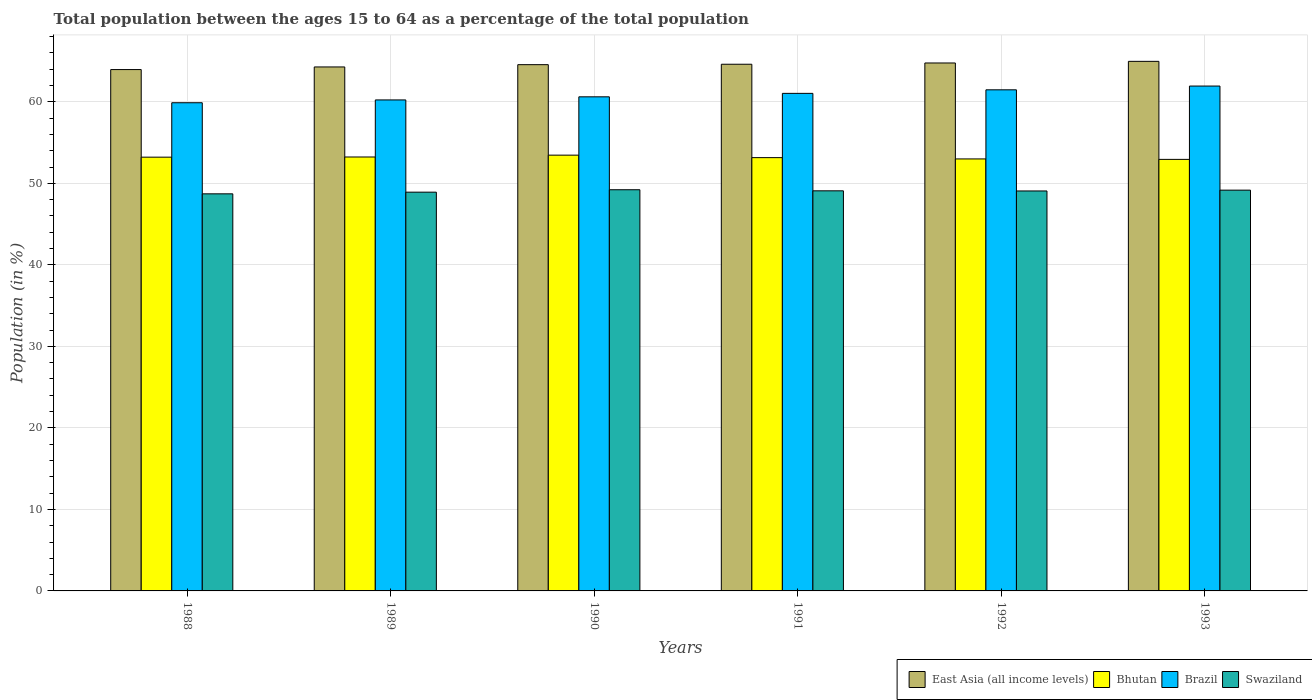How many groups of bars are there?
Make the answer very short. 6. How many bars are there on the 2nd tick from the left?
Keep it short and to the point. 4. How many bars are there on the 4th tick from the right?
Give a very brief answer. 4. In how many cases, is the number of bars for a given year not equal to the number of legend labels?
Keep it short and to the point. 0. What is the percentage of the population ages 15 to 64 in Bhutan in 1991?
Provide a short and direct response. 53.15. Across all years, what is the maximum percentage of the population ages 15 to 64 in East Asia (all income levels)?
Keep it short and to the point. 64.96. Across all years, what is the minimum percentage of the population ages 15 to 64 in East Asia (all income levels)?
Offer a terse response. 63.95. In which year was the percentage of the population ages 15 to 64 in Swaziland maximum?
Offer a terse response. 1990. What is the total percentage of the population ages 15 to 64 in East Asia (all income levels) in the graph?
Make the answer very short. 387.11. What is the difference between the percentage of the population ages 15 to 64 in Brazil in 1989 and that in 1993?
Give a very brief answer. -1.7. What is the difference between the percentage of the population ages 15 to 64 in East Asia (all income levels) in 1992 and the percentage of the population ages 15 to 64 in Brazil in 1993?
Provide a succinct answer. 2.83. What is the average percentage of the population ages 15 to 64 in East Asia (all income levels) per year?
Provide a short and direct response. 64.52. In the year 1992, what is the difference between the percentage of the population ages 15 to 64 in Swaziland and percentage of the population ages 15 to 64 in Brazil?
Ensure brevity in your answer.  -12.41. In how many years, is the percentage of the population ages 15 to 64 in East Asia (all income levels) greater than 6?
Offer a very short reply. 6. What is the ratio of the percentage of the population ages 15 to 64 in Swaziland in 1988 to that in 1989?
Ensure brevity in your answer.  1. Is the percentage of the population ages 15 to 64 in Bhutan in 1989 less than that in 1991?
Keep it short and to the point. No. What is the difference between the highest and the second highest percentage of the population ages 15 to 64 in Bhutan?
Provide a succinct answer. 0.23. What is the difference between the highest and the lowest percentage of the population ages 15 to 64 in Bhutan?
Make the answer very short. 0.52. In how many years, is the percentage of the population ages 15 to 64 in East Asia (all income levels) greater than the average percentage of the population ages 15 to 64 in East Asia (all income levels) taken over all years?
Your answer should be very brief. 4. What does the 2nd bar from the left in 1992 represents?
Give a very brief answer. Bhutan. Is it the case that in every year, the sum of the percentage of the population ages 15 to 64 in East Asia (all income levels) and percentage of the population ages 15 to 64 in Brazil is greater than the percentage of the population ages 15 to 64 in Bhutan?
Offer a very short reply. Yes. How many bars are there?
Offer a very short reply. 24. What is the difference between two consecutive major ticks on the Y-axis?
Ensure brevity in your answer.  10. Are the values on the major ticks of Y-axis written in scientific E-notation?
Make the answer very short. No. Does the graph contain any zero values?
Your answer should be very brief. No. Does the graph contain grids?
Keep it short and to the point. Yes. Where does the legend appear in the graph?
Your answer should be very brief. Bottom right. How many legend labels are there?
Offer a very short reply. 4. What is the title of the graph?
Your answer should be very brief. Total population between the ages 15 to 64 as a percentage of the total population. Does "East Asia (all income levels)" appear as one of the legend labels in the graph?
Give a very brief answer. Yes. What is the label or title of the X-axis?
Offer a terse response. Years. What is the label or title of the Y-axis?
Ensure brevity in your answer.  Population (in %). What is the Population (in %) of East Asia (all income levels) in 1988?
Keep it short and to the point. 63.95. What is the Population (in %) in Bhutan in 1988?
Make the answer very short. 53.21. What is the Population (in %) of Brazil in 1988?
Your answer should be compact. 59.88. What is the Population (in %) of Swaziland in 1988?
Make the answer very short. 48.71. What is the Population (in %) in East Asia (all income levels) in 1989?
Your answer should be compact. 64.27. What is the Population (in %) of Bhutan in 1989?
Your answer should be very brief. 53.23. What is the Population (in %) of Brazil in 1989?
Make the answer very short. 60.23. What is the Population (in %) in Swaziland in 1989?
Your response must be concise. 48.92. What is the Population (in %) of East Asia (all income levels) in 1990?
Provide a succinct answer. 64.55. What is the Population (in %) of Bhutan in 1990?
Keep it short and to the point. 53.45. What is the Population (in %) of Brazil in 1990?
Offer a very short reply. 60.61. What is the Population (in %) of Swaziland in 1990?
Your response must be concise. 49.21. What is the Population (in %) of East Asia (all income levels) in 1991?
Your answer should be very brief. 64.61. What is the Population (in %) in Bhutan in 1991?
Ensure brevity in your answer.  53.15. What is the Population (in %) in Brazil in 1991?
Keep it short and to the point. 61.03. What is the Population (in %) in Swaziland in 1991?
Keep it short and to the point. 49.08. What is the Population (in %) of East Asia (all income levels) in 1992?
Make the answer very short. 64.76. What is the Population (in %) in Bhutan in 1992?
Give a very brief answer. 52.99. What is the Population (in %) of Brazil in 1992?
Offer a very short reply. 61.47. What is the Population (in %) of Swaziland in 1992?
Offer a very short reply. 49.06. What is the Population (in %) of East Asia (all income levels) in 1993?
Your answer should be compact. 64.96. What is the Population (in %) of Bhutan in 1993?
Your answer should be compact. 52.94. What is the Population (in %) of Brazil in 1993?
Your answer should be compact. 61.93. What is the Population (in %) of Swaziland in 1993?
Make the answer very short. 49.16. Across all years, what is the maximum Population (in %) in East Asia (all income levels)?
Your response must be concise. 64.96. Across all years, what is the maximum Population (in %) of Bhutan?
Offer a terse response. 53.45. Across all years, what is the maximum Population (in %) in Brazil?
Provide a short and direct response. 61.93. Across all years, what is the maximum Population (in %) of Swaziland?
Provide a short and direct response. 49.21. Across all years, what is the minimum Population (in %) of East Asia (all income levels)?
Provide a succinct answer. 63.95. Across all years, what is the minimum Population (in %) of Bhutan?
Your response must be concise. 52.94. Across all years, what is the minimum Population (in %) of Brazil?
Give a very brief answer. 59.88. Across all years, what is the minimum Population (in %) in Swaziland?
Ensure brevity in your answer.  48.71. What is the total Population (in %) of East Asia (all income levels) in the graph?
Provide a short and direct response. 387.11. What is the total Population (in %) of Bhutan in the graph?
Provide a succinct answer. 318.97. What is the total Population (in %) of Brazil in the graph?
Ensure brevity in your answer.  365.16. What is the total Population (in %) in Swaziland in the graph?
Ensure brevity in your answer.  294.14. What is the difference between the Population (in %) of East Asia (all income levels) in 1988 and that in 1989?
Your response must be concise. -0.32. What is the difference between the Population (in %) in Bhutan in 1988 and that in 1989?
Keep it short and to the point. -0.02. What is the difference between the Population (in %) in Brazil in 1988 and that in 1989?
Provide a short and direct response. -0.35. What is the difference between the Population (in %) of Swaziland in 1988 and that in 1989?
Your answer should be very brief. -0.2. What is the difference between the Population (in %) of East Asia (all income levels) in 1988 and that in 1990?
Your response must be concise. -0.6. What is the difference between the Population (in %) of Bhutan in 1988 and that in 1990?
Ensure brevity in your answer.  -0.25. What is the difference between the Population (in %) of Brazil in 1988 and that in 1990?
Your answer should be compact. -0.73. What is the difference between the Population (in %) of Swaziland in 1988 and that in 1990?
Offer a very short reply. -0.5. What is the difference between the Population (in %) in East Asia (all income levels) in 1988 and that in 1991?
Ensure brevity in your answer.  -0.65. What is the difference between the Population (in %) of Bhutan in 1988 and that in 1991?
Offer a terse response. 0.06. What is the difference between the Population (in %) in Brazil in 1988 and that in 1991?
Offer a very short reply. -1.15. What is the difference between the Population (in %) in Swaziland in 1988 and that in 1991?
Provide a succinct answer. -0.37. What is the difference between the Population (in %) in East Asia (all income levels) in 1988 and that in 1992?
Give a very brief answer. -0.81. What is the difference between the Population (in %) in Bhutan in 1988 and that in 1992?
Your answer should be compact. 0.22. What is the difference between the Population (in %) of Brazil in 1988 and that in 1992?
Offer a very short reply. -1.59. What is the difference between the Population (in %) of Swaziland in 1988 and that in 1992?
Provide a short and direct response. -0.35. What is the difference between the Population (in %) of East Asia (all income levels) in 1988 and that in 1993?
Keep it short and to the point. -1.01. What is the difference between the Population (in %) of Bhutan in 1988 and that in 1993?
Provide a short and direct response. 0.27. What is the difference between the Population (in %) in Brazil in 1988 and that in 1993?
Your response must be concise. -2.05. What is the difference between the Population (in %) of Swaziland in 1988 and that in 1993?
Your answer should be very brief. -0.45. What is the difference between the Population (in %) in East Asia (all income levels) in 1989 and that in 1990?
Provide a succinct answer. -0.28. What is the difference between the Population (in %) of Bhutan in 1989 and that in 1990?
Make the answer very short. -0.23. What is the difference between the Population (in %) in Brazil in 1989 and that in 1990?
Your answer should be very brief. -0.38. What is the difference between the Population (in %) in Swaziland in 1989 and that in 1990?
Your response must be concise. -0.3. What is the difference between the Population (in %) in East Asia (all income levels) in 1989 and that in 1991?
Provide a short and direct response. -0.33. What is the difference between the Population (in %) of Bhutan in 1989 and that in 1991?
Offer a terse response. 0.08. What is the difference between the Population (in %) of Brazil in 1989 and that in 1991?
Your answer should be compact. -0.81. What is the difference between the Population (in %) of Swaziland in 1989 and that in 1991?
Give a very brief answer. -0.16. What is the difference between the Population (in %) of East Asia (all income levels) in 1989 and that in 1992?
Make the answer very short. -0.49. What is the difference between the Population (in %) of Bhutan in 1989 and that in 1992?
Provide a succinct answer. 0.24. What is the difference between the Population (in %) in Brazil in 1989 and that in 1992?
Give a very brief answer. -1.24. What is the difference between the Population (in %) in Swaziland in 1989 and that in 1992?
Your response must be concise. -0.15. What is the difference between the Population (in %) of East Asia (all income levels) in 1989 and that in 1993?
Give a very brief answer. -0.69. What is the difference between the Population (in %) of Bhutan in 1989 and that in 1993?
Ensure brevity in your answer.  0.29. What is the difference between the Population (in %) of Brazil in 1989 and that in 1993?
Your response must be concise. -1.7. What is the difference between the Population (in %) of Swaziland in 1989 and that in 1993?
Offer a very short reply. -0.25. What is the difference between the Population (in %) in East Asia (all income levels) in 1990 and that in 1991?
Your response must be concise. -0.05. What is the difference between the Population (in %) of Bhutan in 1990 and that in 1991?
Offer a very short reply. 0.3. What is the difference between the Population (in %) in Brazil in 1990 and that in 1991?
Offer a very short reply. -0.42. What is the difference between the Population (in %) in Swaziland in 1990 and that in 1991?
Provide a short and direct response. 0.13. What is the difference between the Population (in %) of East Asia (all income levels) in 1990 and that in 1992?
Your response must be concise. -0.21. What is the difference between the Population (in %) of Bhutan in 1990 and that in 1992?
Your answer should be compact. 0.46. What is the difference between the Population (in %) of Brazil in 1990 and that in 1992?
Provide a succinct answer. -0.86. What is the difference between the Population (in %) in Swaziland in 1990 and that in 1992?
Make the answer very short. 0.15. What is the difference between the Population (in %) in East Asia (all income levels) in 1990 and that in 1993?
Provide a short and direct response. -0.41. What is the difference between the Population (in %) of Bhutan in 1990 and that in 1993?
Give a very brief answer. 0.52. What is the difference between the Population (in %) in Brazil in 1990 and that in 1993?
Offer a terse response. -1.32. What is the difference between the Population (in %) of Swaziland in 1990 and that in 1993?
Your answer should be very brief. 0.05. What is the difference between the Population (in %) of East Asia (all income levels) in 1991 and that in 1992?
Provide a succinct answer. -0.15. What is the difference between the Population (in %) of Bhutan in 1991 and that in 1992?
Offer a terse response. 0.16. What is the difference between the Population (in %) in Brazil in 1991 and that in 1992?
Your response must be concise. -0.44. What is the difference between the Population (in %) in Swaziland in 1991 and that in 1992?
Give a very brief answer. 0.02. What is the difference between the Population (in %) of East Asia (all income levels) in 1991 and that in 1993?
Make the answer very short. -0.35. What is the difference between the Population (in %) of Bhutan in 1991 and that in 1993?
Your answer should be compact. 0.22. What is the difference between the Population (in %) in Brazil in 1991 and that in 1993?
Provide a short and direct response. -0.9. What is the difference between the Population (in %) of Swaziland in 1991 and that in 1993?
Make the answer very short. -0.08. What is the difference between the Population (in %) of East Asia (all income levels) in 1992 and that in 1993?
Your response must be concise. -0.2. What is the difference between the Population (in %) of Bhutan in 1992 and that in 1993?
Provide a short and direct response. 0.06. What is the difference between the Population (in %) of Brazil in 1992 and that in 1993?
Make the answer very short. -0.46. What is the difference between the Population (in %) in Swaziland in 1992 and that in 1993?
Make the answer very short. -0.1. What is the difference between the Population (in %) in East Asia (all income levels) in 1988 and the Population (in %) in Bhutan in 1989?
Your answer should be compact. 10.72. What is the difference between the Population (in %) of East Asia (all income levels) in 1988 and the Population (in %) of Brazil in 1989?
Your response must be concise. 3.72. What is the difference between the Population (in %) in East Asia (all income levels) in 1988 and the Population (in %) in Swaziland in 1989?
Make the answer very short. 15.04. What is the difference between the Population (in %) of Bhutan in 1988 and the Population (in %) of Brazil in 1989?
Keep it short and to the point. -7.02. What is the difference between the Population (in %) of Bhutan in 1988 and the Population (in %) of Swaziland in 1989?
Provide a succinct answer. 4.29. What is the difference between the Population (in %) of Brazil in 1988 and the Population (in %) of Swaziland in 1989?
Offer a very short reply. 10.97. What is the difference between the Population (in %) in East Asia (all income levels) in 1988 and the Population (in %) in Bhutan in 1990?
Make the answer very short. 10.5. What is the difference between the Population (in %) of East Asia (all income levels) in 1988 and the Population (in %) of Brazil in 1990?
Ensure brevity in your answer.  3.34. What is the difference between the Population (in %) of East Asia (all income levels) in 1988 and the Population (in %) of Swaziland in 1990?
Provide a succinct answer. 14.74. What is the difference between the Population (in %) of Bhutan in 1988 and the Population (in %) of Brazil in 1990?
Make the answer very short. -7.4. What is the difference between the Population (in %) of Bhutan in 1988 and the Population (in %) of Swaziland in 1990?
Give a very brief answer. 4. What is the difference between the Population (in %) in Brazil in 1988 and the Population (in %) in Swaziland in 1990?
Your answer should be compact. 10.67. What is the difference between the Population (in %) of East Asia (all income levels) in 1988 and the Population (in %) of Bhutan in 1991?
Keep it short and to the point. 10.8. What is the difference between the Population (in %) of East Asia (all income levels) in 1988 and the Population (in %) of Brazil in 1991?
Your answer should be compact. 2.92. What is the difference between the Population (in %) in East Asia (all income levels) in 1988 and the Population (in %) in Swaziland in 1991?
Offer a terse response. 14.87. What is the difference between the Population (in %) in Bhutan in 1988 and the Population (in %) in Brazil in 1991?
Your answer should be very brief. -7.83. What is the difference between the Population (in %) of Bhutan in 1988 and the Population (in %) of Swaziland in 1991?
Your response must be concise. 4.13. What is the difference between the Population (in %) of Brazil in 1988 and the Population (in %) of Swaziland in 1991?
Ensure brevity in your answer.  10.81. What is the difference between the Population (in %) of East Asia (all income levels) in 1988 and the Population (in %) of Bhutan in 1992?
Ensure brevity in your answer.  10.96. What is the difference between the Population (in %) of East Asia (all income levels) in 1988 and the Population (in %) of Brazil in 1992?
Make the answer very short. 2.48. What is the difference between the Population (in %) of East Asia (all income levels) in 1988 and the Population (in %) of Swaziland in 1992?
Make the answer very short. 14.89. What is the difference between the Population (in %) of Bhutan in 1988 and the Population (in %) of Brazil in 1992?
Ensure brevity in your answer.  -8.26. What is the difference between the Population (in %) in Bhutan in 1988 and the Population (in %) in Swaziland in 1992?
Your answer should be compact. 4.14. What is the difference between the Population (in %) in Brazil in 1988 and the Population (in %) in Swaziland in 1992?
Your answer should be very brief. 10.82. What is the difference between the Population (in %) in East Asia (all income levels) in 1988 and the Population (in %) in Bhutan in 1993?
Offer a terse response. 11.02. What is the difference between the Population (in %) in East Asia (all income levels) in 1988 and the Population (in %) in Brazil in 1993?
Provide a succinct answer. 2.02. What is the difference between the Population (in %) of East Asia (all income levels) in 1988 and the Population (in %) of Swaziland in 1993?
Offer a terse response. 14.79. What is the difference between the Population (in %) in Bhutan in 1988 and the Population (in %) in Brazil in 1993?
Your answer should be very brief. -8.72. What is the difference between the Population (in %) in Bhutan in 1988 and the Population (in %) in Swaziland in 1993?
Keep it short and to the point. 4.04. What is the difference between the Population (in %) in Brazil in 1988 and the Population (in %) in Swaziland in 1993?
Ensure brevity in your answer.  10.72. What is the difference between the Population (in %) of East Asia (all income levels) in 1989 and the Population (in %) of Bhutan in 1990?
Provide a succinct answer. 10.82. What is the difference between the Population (in %) in East Asia (all income levels) in 1989 and the Population (in %) in Brazil in 1990?
Make the answer very short. 3.66. What is the difference between the Population (in %) in East Asia (all income levels) in 1989 and the Population (in %) in Swaziland in 1990?
Provide a short and direct response. 15.06. What is the difference between the Population (in %) in Bhutan in 1989 and the Population (in %) in Brazil in 1990?
Your answer should be very brief. -7.38. What is the difference between the Population (in %) in Bhutan in 1989 and the Population (in %) in Swaziland in 1990?
Provide a short and direct response. 4.02. What is the difference between the Population (in %) in Brazil in 1989 and the Population (in %) in Swaziland in 1990?
Your answer should be compact. 11.02. What is the difference between the Population (in %) of East Asia (all income levels) in 1989 and the Population (in %) of Bhutan in 1991?
Provide a succinct answer. 11.12. What is the difference between the Population (in %) of East Asia (all income levels) in 1989 and the Population (in %) of Brazil in 1991?
Ensure brevity in your answer.  3.24. What is the difference between the Population (in %) in East Asia (all income levels) in 1989 and the Population (in %) in Swaziland in 1991?
Keep it short and to the point. 15.2. What is the difference between the Population (in %) of Bhutan in 1989 and the Population (in %) of Brazil in 1991?
Your answer should be very brief. -7.8. What is the difference between the Population (in %) in Bhutan in 1989 and the Population (in %) in Swaziland in 1991?
Offer a terse response. 4.15. What is the difference between the Population (in %) of Brazil in 1989 and the Population (in %) of Swaziland in 1991?
Provide a succinct answer. 11.15. What is the difference between the Population (in %) in East Asia (all income levels) in 1989 and the Population (in %) in Bhutan in 1992?
Give a very brief answer. 11.28. What is the difference between the Population (in %) in East Asia (all income levels) in 1989 and the Population (in %) in Brazil in 1992?
Give a very brief answer. 2.8. What is the difference between the Population (in %) in East Asia (all income levels) in 1989 and the Population (in %) in Swaziland in 1992?
Provide a short and direct response. 15.21. What is the difference between the Population (in %) in Bhutan in 1989 and the Population (in %) in Brazil in 1992?
Provide a succinct answer. -8.24. What is the difference between the Population (in %) of Bhutan in 1989 and the Population (in %) of Swaziland in 1992?
Your response must be concise. 4.17. What is the difference between the Population (in %) of Brazil in 1989 and the Population (in %) of Swaziland in 1992?
Keep it short and to the point. 11.17. What is the difference between the Population (in %) in East Asia (all income levels) in 1989 and the Population (in %) in Bhutan in 1993?
Offer a terse response. 11.34. What is the difference between the Population (in %) in East Asia (all income levels) in 1989 and the Population (in %) in Brazil in 1993?
Offer a very short reply. 2.34. What is the difference between the Population (in %) of East Asia (all income levels) in 1989 and the Population (in %) of Swaziland in 1993?
Offer a very short reply. 15.11. What is the difference between the Population (in %) of Bhutan in 1989 and the Population (in %) of Brazil in 1993?
Offer a very short reply. -8.7. What is the difference between the Population (in %) in Bhutan in 1989 and the Population (in %) in Swaziland in 1993?
Provide a succinct answer. 4.07. What is the difference between the Population (in %) of Brazil in 1989 and the Population (in %) of Swaziland in 1993?
Ensure brevity in your answer.  11.07. What is the difference between the Population (in %) in East Asia (all income levels) in 1990 and the Population (in %) in Bhutan in 1991?
Make the answer very short. 11.4. What is the difference between the Population (in %) of East Asia (all income levels) in 1990 and the Population (in %) of Brazil in 1991?
Your answer should be very brief. 3.52. What is the difference between the Population (in %) of East Asia (all income levels) in 1990 and the Population (in %) of Swaziland in 1991?
Make the answer very short. 15.48. What is the difference between the Population (in %) in Bhutan in 1990 and the Population (in %) in Brazil in 1991?
Provide a short and direct response. -7.58. What is the difference between the Population (in %) of Bhutan in 1990 and the Population (in %) of Swaziland in 1991?
Your answer should be compact. 4.38. What is the difference between the Population (in %) of Brazil in 1990 and the Population (in %) of Swaziland in 1991?
Provide a short and direct response. 11.53. What is the difference between the Population (in %) of East Asia (all income levels) in 1990 and the Population (in %) of Bhutan in 1992?
Your response must be concise. 11.56. What is the difference between the Population (in %) of East Asia (all income levels) in 1990 and the Population (in %) of Brazil in 1992?
Provide a succinct answer. 3.09. What is the difference between the Population (in %) in East Asia (all income levels) in 1990 and the Population (in %) in Swaziland in 1992?
Ensure brevity in your answer.  15.49. What is the difference between the Population (in %) of Bhutan in 1990 and the Population (in %) of Brazil in 1992?
Your answer should be very brief. -8.01. What is the difference between the Population (in %) in Bhutan in 1990 and the Population (in %) in Swaziland in 1992?
Provide a short and direct response. 4.39. What is the difference between the Population (in %) of Brazil in 1990 and the Population (in %) of Swaziland in 1992?
Offer a terse response. 11.55. What is the difference between the Population (in %) in East Asia (all income levels) in 1990 and the Population (in %) in Bhutan in 1993?
Make the answer very short. 11.62. What is the difference between the Population (in %) in East Asia (all income levels) in 1990 and the Population (in %) in Brazil in 1993?
Provide a succinct answer. 2.62. What is the difference between the Population (in %) in East Asia (all income levels) in 1990 and the Population (in %) in Swaziland in 1993?
Make the answer very short. 15.39. What is the difference between the Population (in %) of Bhutan in 1990 and the Population (in %) of Brazil in 1993?
Your answer should be very brief. -8.48. What is the difference between the Population (in %) in Bhutan in 1990 and the Population (in %) in Swaziland in 1993?
Keep it short and to the point. 4.29. What is the difference between the Population (in %) of Brazil in 1990 and the Population (in %) of Swaziland in 1993?
Your response must be concise. 11.45. What is the difference between the Population (in %) of East Asia (all income levels) in 1991 and the Population (in %) of Bhutan in 1992?
Ensure brevity in your answer.  11.61. What is the difference between the Population (in %) in East Asia (all income levels) in 1991 and the Population (in %) in Brazil in 1992?
Your answer should be compact. 3.14. What is the difference between the Population (in %) of East Asia (all income levels) in 1991 and the Population (in %) of Swaziland in 1992?
Provide a short and direct response. 15.54. What is the difference between the Population (in %) of Bhutan in 1991 and the Population (in %) of Brazil in 1992?
Offer a very short reply. -8.32. What is the difference between the Population (in %) of Bhutan in 1991 and the Population (in %) of Swaziland in 1992?
Your response must be concise. 4.09. What is the difference between the Population (in %) in Brazil in 1991 and the Population (in %) in Swaziland in 1992?
Make the answer very short. 11.97. What is the difference between the Population (in %) of East Asia (all income levels) in 1991 and the Population (in %) of Bhutan in 1993?
Your response must be concise. 11.67. What is the difference between the Population (in %) in East Asia (all income levels) in 1991 and the Population (in %) in Brazil in 1993?
Give a very brief answer. 2.68. What is the difference between the Population (in %) of East Asia (all income levels) in 1991 and the Population (in %) of Swaziland in 1993?
Your answer should be compact. 15.44. What is the difference between the Population (in %) of Bhutan in 1991 and the Population (in %) of Brazil in 1993?
Provide a short and direct response. -8.78. What is the difference between the Population (in %) of Bhutan in 1991 and the Population (in %) of Swaziland in 1993?
Offer a terse response. 3.99. What is the difference between the Population (in %) in Brazil in 1991 and the Population (in %) in Swaziland in 1993?
Offer a terse response. 11.87. What is the difference between the Population (in %) of East Asia (all income levels) in 1992 and the Population (in %) of Bhutan in 1993?
Provide a succinct answer. 11.82. What is the difference between the Population (in %) in East Asia (all income levels) in 1992 and the Population (in %) in Brazil in 1993?
Your response must be concise. 2.83. What is the difference between the Population (in %) in East Asia (all income levels) in 1992 and the Population (in %) in Swaziland in 1993?
Provide a short and direct response. 15.6. What is the difference between the Population (in %) of Bhutan in 1992 and the Population (in %) of Brazil in 1993?
Provide a short and direct response. -8.94. What is the difference between the Population (in %) of Bhutan in 1992 and the Population (in %) of Swaziland in 1993?
Keep it short and to the point. 3.83. What is the difference between the Population (in %) in Brazil in 1992 and the Population (in %) in Swaziland in 1993?
Your answer should be compact. 12.31. What is the average Population (in %) of East Asia (all income levels) per year?
Give a very brief answer. 64.52. What is the average Population (in %) of Bhutan per year?
Give a very brief answer. 53.16. What is the average Population (in %) of Brazil per year?
Provide a short and direct response. 60.86. What is the average Population (in %) in Swaziland per year?
Offer a very short reply. 49.02. In the year 1988, what is the difference between the Population (in %) in East Asia (all income levels) and Population (in %) in Bhutan?
Offer a terse response. 10.75. In the year 1988, what is the difference between the Population (in %) of East Asia (all income levels) and Population (in %) of Brazil?
Your answer should be compact. 4.07. In the year 1988, what is the difference between the Population (in %) in East Asia (all income levels) and Population (in %) in Swaziland?
Your answer should be very brief. 15.24. In the year 1988, what is the difference between the Population (in %) of Bhutan and Population (in %) of Brazil?
Offer a very short reply. -6.68. In the year 1988, what is the difference between the Population (in %) of Bhutan and Population (in %) of Swaziland?
Ensure brevity in your answer.  4.5. In the year 1988, what is the difference between the Population (in %) in Brazil and Population (in %) in Swaziland?
Offer a very short reply. 11.17. In the year 1989, what is the difference between the Population (in %) in East Asia (all income levels) and Population (in %) in Bhutan?
Make the answer very short. 11.04. In the year 1989, what is the difference between the Population (in %) of East Asia (all income levels) and Population (in %) of Brazil?
Provide a succinct answer. 4.04. In the year 1989, what is the difference between the Population (in %) of East Asia (all income levels) and Population (in %) of Swaziland?
Offer a very short reply. 15.36. In the year 1989, what is the difference between the Population (in %) of Bhutan and Population (in %) of Brazil?
Ensure brevity in your answer.  -7. In the year 1989, what is the difference between the Population (in %) in Bhutan and Population (in %) in Swaziland?
Offer a very short reply. 4.31. In the year 1989, what is the difference between the Population (in %) in Brazil and Population (in %) in Swaziland?
Offer a terse response. 11.31. In the year 1990, what is the difference between the Population (in %) of East Asia (all income levels) and Population (in %) of Brazil?
Offer a terse response. 3.95. In the year 1990, what is the difference between the Population (in %) in East Asia (all income levels) and Population (in %) in Swaziland?
Your answer should be very brief. 15.34. In the year 1990, what is the difference between the Population (in %) in Bhutan and Population (in %) in Brazil?
Provide a succinct answer. -7.15. In the year 1990, what is the difference between the Population (in %) of Bhutan and Population (in %) of Swaziland?
Offer a terse response. 4.24. In the year 1990, what is the difference between the Population (in %) in Brazil and Population (in %) in Swaziland?
Provide a succinct answer. 11.4. In the year 1991, what is the difference between the Population (in %) of East Asia (all income levels) and Population (in %) of Bhutan?
Keep it short and to the point. 11.46. In the year 1991, what is the difference between the Population (in %) of East Asia (all income levels) and Population (in %) of Brazil?
Give a very brief answer. 3.57. In the year 1991, what is the difference between the Population (in %) in East Asia (all income levels) and Population (in %) in Swaziland?
Give a very brief answer. 15.53. In the year 1991, what is the difference between the Population (in %) in Bhutan and Population (in %) in Brazil?
Provide a succinct answer. -7.88. In the year 1991, what is the difference between the Population (in %) of Bhutan and Population (in %) of Swaziland?
Keep it short and to the point. 4.07. In the year 1991, what is the difference between the Population (in %) of Brazil and Population (in %) of Swaziland?
Ensure brevity in your answer.  11.96. In the year 1992, what is the difference between the Population (in %) of East Asia (all income levels) and Population (in %) of Bhutan?
Provide a succinct answer. 11.77. In the year 1992, what is the difference between the Population (in %) of East Asia (all income levels) and Population (in %) of Brazil?
Offer a terse response. 3.29. In the year 1992, what is the difference between the Population (in %) in East Asia (all income levels) and Population (in %) in Swaziland?
Your answer should be compact. 15.7. In the year 1992, what is the difference between the Population (in %) in Bhutan and Population (in %) in Brazil?
Provide a short and direct response. -8.48. In the year 1992, what is the difference between the Population (in %) of Bhutan and Population (in %) of Swaziland?
Your answer should be very brief. 3.93. In the year 1992, what is the difference between the Population (in %) of Brazil and Population (in %) of Swaziland?
Offer a terse response. 12.41. In the year 1993, what is the difference between the Population (in %) in East Asia (all income levels) and Population (in %) in Bhutan?
Provide a succinct answer. 12.03. In the year 1993, what is the difference between the Population (in %) of East Asia (all income levels) and Population (in %) of Brazil?
Provide a succinct answer. 3.03. In the year 1993, what is the difference between the Population (in %) in East Asia (all income levels) and Population (in %) in Swaziland?
Your response must be concise. 15.8. In the year 1993, what is the difference between the Population (in %) of Bhutan and Population (in %) of Brazil?
Provide a succinct answer. -8.99. In the year 1993, what is the difference between the Population (in %) of Bhutan and Population (in %) of Swaziland?
Your response must be concise. 3.77. In the year 1993, what is the difference between the Population (in %) of Brazil and Population (in %) of Swaziland?
Provide a short and direct response. 12.77. What is the ratio of the Population (in %) in East Asia (all income levels) in 1988 to that in 1989?
Your answer should be compact. 0.99. What is the ratio of the Population (in %) in Brazil in 1988 to that in 1989?
Keep it short and to the point. 0.99. What is the ratio of the Population (in %) of Swaziland in 1988 to that in 1990?
Keep it short and to the point. 0.99. What is the ratio of the Population (in %) in East Asia (all income levels) in 1988 to that in 1991?
Your answer should be compact. 0.99. What is the ratio of the Population (in %) of Brazil in 1988 to that in 1991?
Give a very brief answer. 0.98. What is the ratio of the Population (in %) of East Asia (all income levels) in 1988 to that in 1992?
Your response must be concise. 0.99. What is the ratio of the Population (in %) of Brazil in 1988 to that in 1992?
Provide a succinct answer. 0.97. What is the ratio of the Population (in %) of Swaziland in 1988 to that in 1992?
Your answer should be compact. 0.99. What is the ratio of the Population (in %) of East Asia (all income levels) in 1988 to that in 1993?
Provide a short and direct response. 0.98. What is the ratio of the Population (in %) in Brazil in 1988 to that in 1993?
Offer a terse response. 0.97. What is the ratio of the Population (in %) of East Asia (all income levels) in 1989 to that in 1990?
Your answer should be compact. 1. What is the ratio of the Population (in %) in Bhutan in 1989 to that in 1990?
Provide a succinct answer. 1. What is the ratio of the Population (in %) in Swaziland in 1989 to that in 1990?
Your answer should be very brief. 0.99. What is the ratio of the Population (in %) of Bhutan in 1989 to that in 1991?
Ensure brevity in your answer.  1. What is the ratio of the Population (in %) of Brazil in 1989 to that in 1991?
Give a very brief answer. 0.99. What is the ratio of the Population (in %) in Swaziland in 1989 to that in 1991?
Your answer should be compact. 1. What is the ratio of the Population (in %) of East Asia (all income levels) in 1989 to that in 1992?
Give a very brief answer. 0.99. What is the ratio of the Population (in %) of Bhutan in 1989 to that in 1992?
Your answer should be compact. 1. What is the ratio of the Population (in %) of Brazil in 1989 to that in 1992?
Make the answer very short. 0.98. What is the ratio of the Population (in %) in Swaziland in 1989 to that in 1992?
Provide a short and direct response. 1. What is the ratio of the Population (in %) in East Asia (all income levels) in 1989 to that in 1993?
Your answer should be very brief. 0.99. What is the ratio of the Population (in %) of Bhutan in 1989 to that in 1993?
Provide a succinct answer. 1.01. What is the ratio of the Population (in %) in Brazil in 1989 to that in 1993?
Keep it short and to the point. 0.97. What is the ratio of the Population (in %) of Swaziland in 1989 to that in 1993?
Provide a succinct answer. 0.99. What is the ratio of the Population (in %) of East Asia (all income levels) in 1990 to that in 1991?
Provide a succinct answer. 1. What is the ratio of the Population (in %) of Bhutan in 1990 to that in 1991?
Make the answer very short. 1.01. What is the ratio of the Population (in %) of Bhutan in 1990 to that in 1992?
Your answer should be very brief. 1.01. What is the ratio of the Population (in %) in Brazil in 1990 to that in 1992?
Ensure brevity in your answer.  0.99. What is the ratio of the Population (in %) in East Asia (all income levels) in 1990 to that in 1993?
Give a very brief answer. 0.99. What is the ratio of the Population (in %) in Bhutan in 1990 to that in 1993?
Your response must be concise. 1.01. What is the ratio of the Population (in %) in Brazil in 1990 to that in 1993?
Your answer should be compact. 0.98. What is the ratio of the Population (in %) in East Asia (all income levels) in 1991 to that in 1993?
Your answer should be compact. 0.99. What is the ratio of the Population (in %) in Brazil in 1991 to that in 1993?
Provide a succinct answer. 0.99. What is the ratio of the Population (in %) in East Asia (all income levels) in 1992 to that in 1993?
Your answer should be very brief. 1. What is the ratio of the Population (in %) in Bhutan in 1992 to that in 1993?
Make the answer very short. 1. What is the ratio of the Population (in %) of Brazil in 1992 to that in 1993?
Make the answer very short. 0.99. What is the difference between the highest and the second highest Population (in %) of Bhutan?
Your answer should be compact. 0.23. What is the difference between the highest and the second highest Population (in %) of Brazil?
Offer a very short reply. 0.46. What is the difference between the highest and the second highest Population (in %) in Swaziland?
Your response must be concise. 0.05. What is the difference between the highest and the lowest Population (in %) of East Asia (all income levels)?
Your answer should be compact. 1.01. What is the difference between the highest and the lowest Population (in %) of Bhutan?
Provide a succinct answer. 0.52. What is the difference between the highest and the lowest Population (in %) of Brazil?
Give a very brief answer. 2.05. What is the difference between the highest and the lowest Population (in %) in Swaziland?
Your response must be concise. 0.5. 